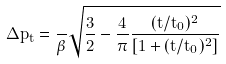<formula> <loc_0><loc_0><loc_500><loc_500>\Delta p _ { t } = \frac { } { \beta } \sqrt { \frac { 3 } { 2 } - \frac { 4 } { \pi } \frac { ( t / t _ { 0 } ) ^ { 2 } } { [ 1 + ( t / t _ { 0 } ) ^ { 2 } ] } }</formula> 